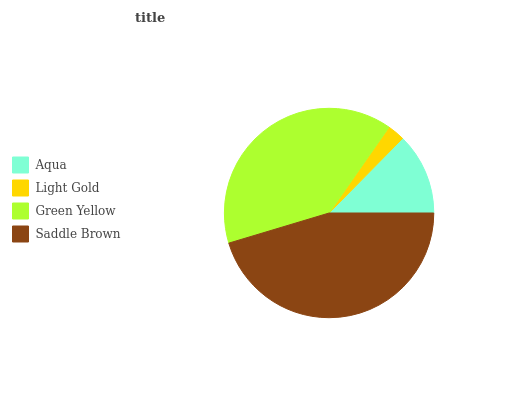Is Light Gold the minimum?
Answer yes or no. Yes. Is Saddle Brown the maximum?
Answer yes or no. Yes. Is Green Yellow the minimum?
Answer yes or no. No. Is Green Yellow the maximum?
Answer yes or no. No. Is Green Yellow greater than Light Gold?
Answer yes or no. Yes. Is Light Gold less than Green Yellow?
Answer yes or no. Yes. Is Light Gold greater than Green Yellow?
Answer yes or no. No. Is Green Yellow less than Light Gold?
Answer yes or no. No. Is Green Yellow the high median?
Answer yes or no. Yes. Is Aqua the low median?
Answer yes or no. Yes. Is Aqua the high median?
Answer yes or no. No. Is Light Gold the low median?
Answer yes or no. No. 